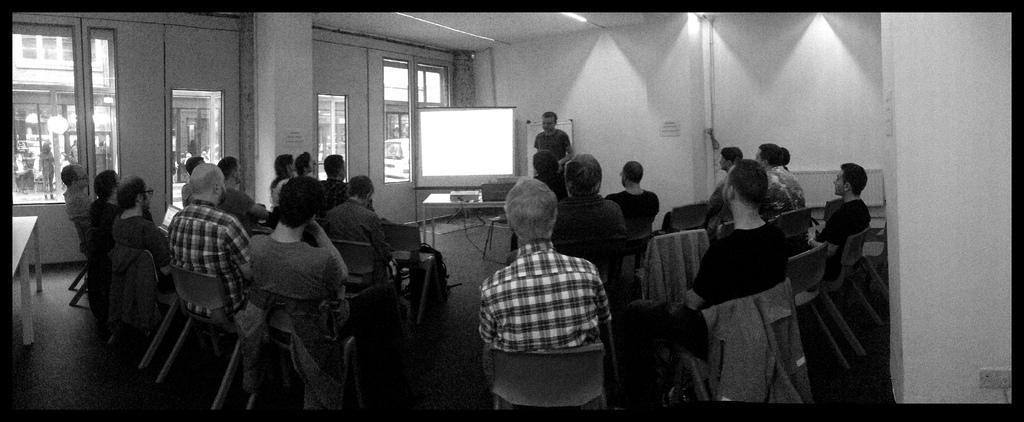In one or two sentences, can you explain what this image depicts? This is a black and white image where we can see these people are sitting on the chairs and this person is standing near table where projector and laptop are kept. Here we can see the projector screen, we can see glass doors, pillar and ceiling lights in the background. 